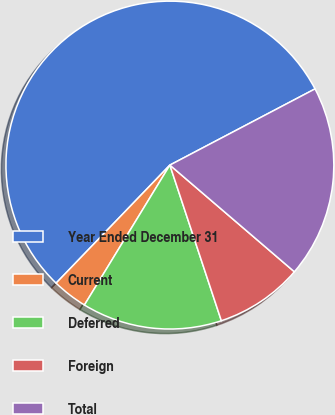<chart> <loc_0><loc_0><loc_500><loc_500><pie_chart><fcel>Year Ended December 31<fcel>Current<fcel>Deferred<fcel>Foreign<fcel>Total<nl><fcel>55.1%<fcel>3.48%<fcel>13.81%<fcel>8.64%<fcel>18.97%<nl></chart> 